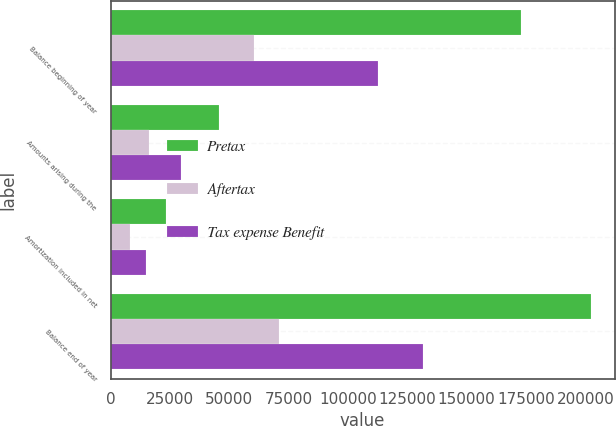Convert chart. <chart><loc_0><loc_0><loc_500><loc_500><stacked_bar_chart><ecel><fcel>Balance beginning of year<fcel>Amounts arising during the<fcel>Amortization included in net<fcel>Balance end of year<nl><fcel>Pretax<fcel>173029<fcel>45804<fcel>23313<fcel>202292<nl><fcel>Aftertax<fcel>60561<fcel>16031<fcel>8159<fcel>70803<nl><fcel>Tax expense Benefit<fcel>112468<fcel>29773<fcel>15154<fcel>131489<nl></chart> 